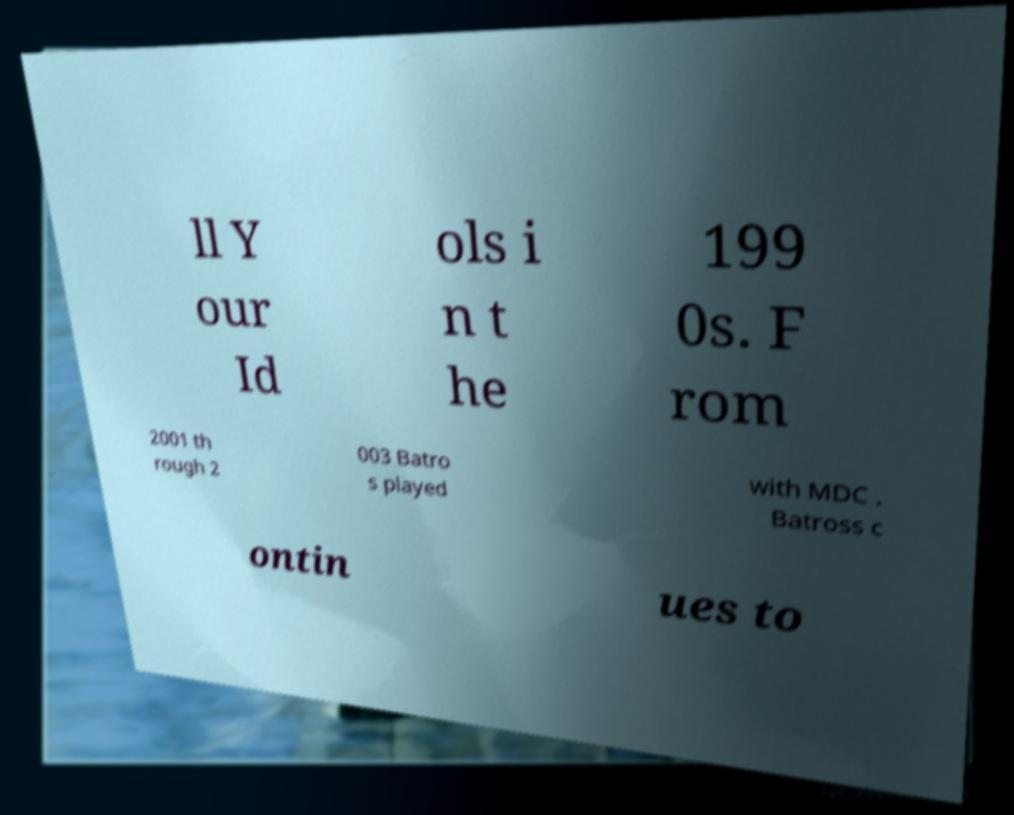Please identify and transcribe the text found in this image. ll Y our Id ols i n t he 199 0s. F rom 2001 th rough 2 003 Batro s played with MDC . Batross c ontin ues to 